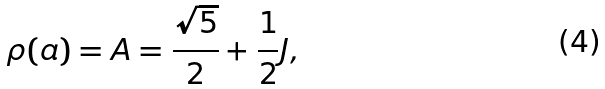Convert formula to latex. <formula><loc_0><loc_0><loc_500><loc_500>\rho ( a ) = A = \frac { \sqrt { 5 } } { 2 } + \frac { 1 } { 2 } J ,</formula> 